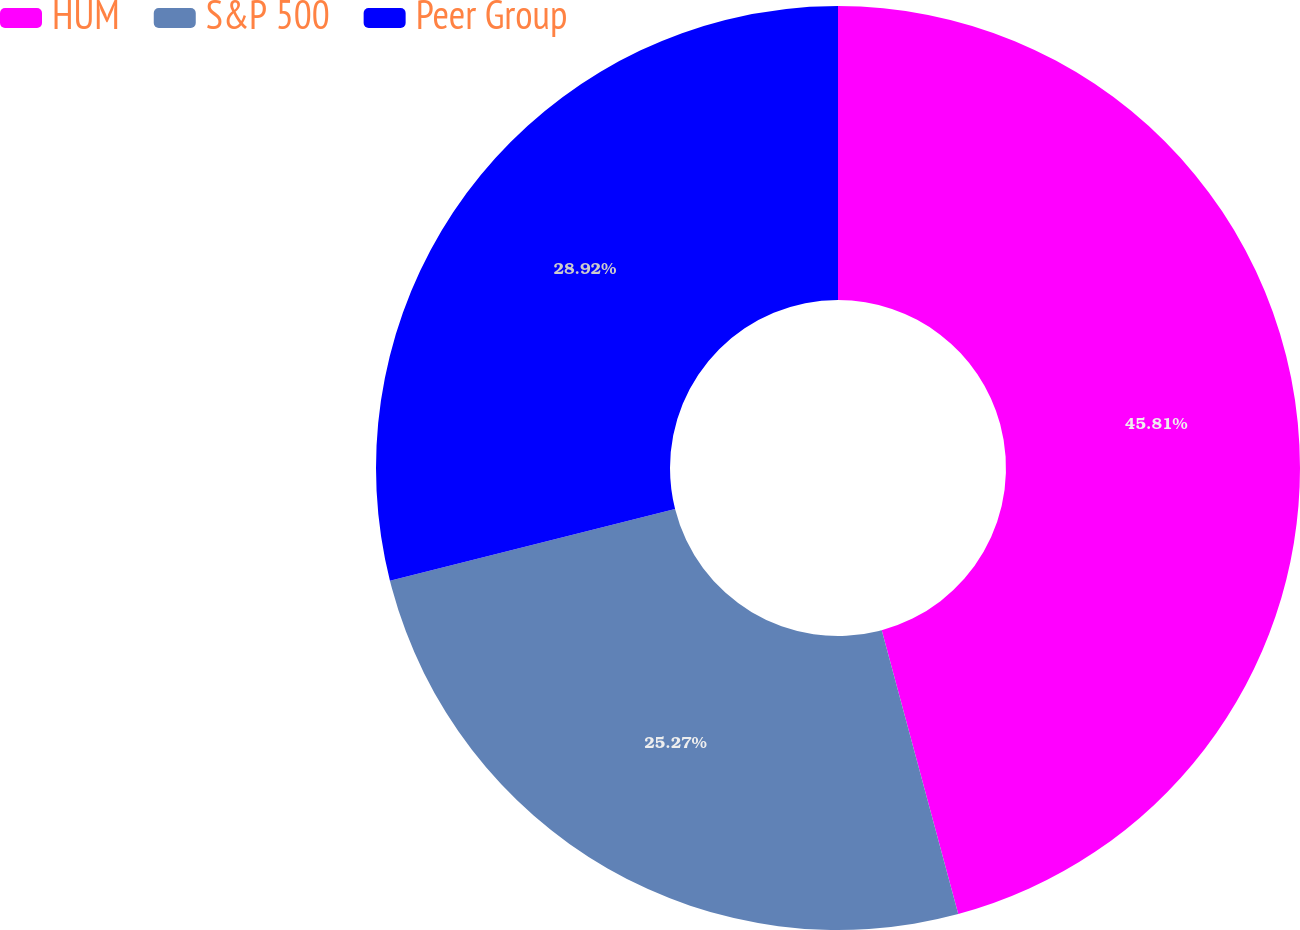Convert chart. <chart><loc_0><loc_0><loc_500><loc_500><pie_chart><fcel>HUM<fcel>S&P 500<fcel>Peer Group<nl><fcel>45.81%<fcel>25.27%<fcel>28.92%<nl></chart> 